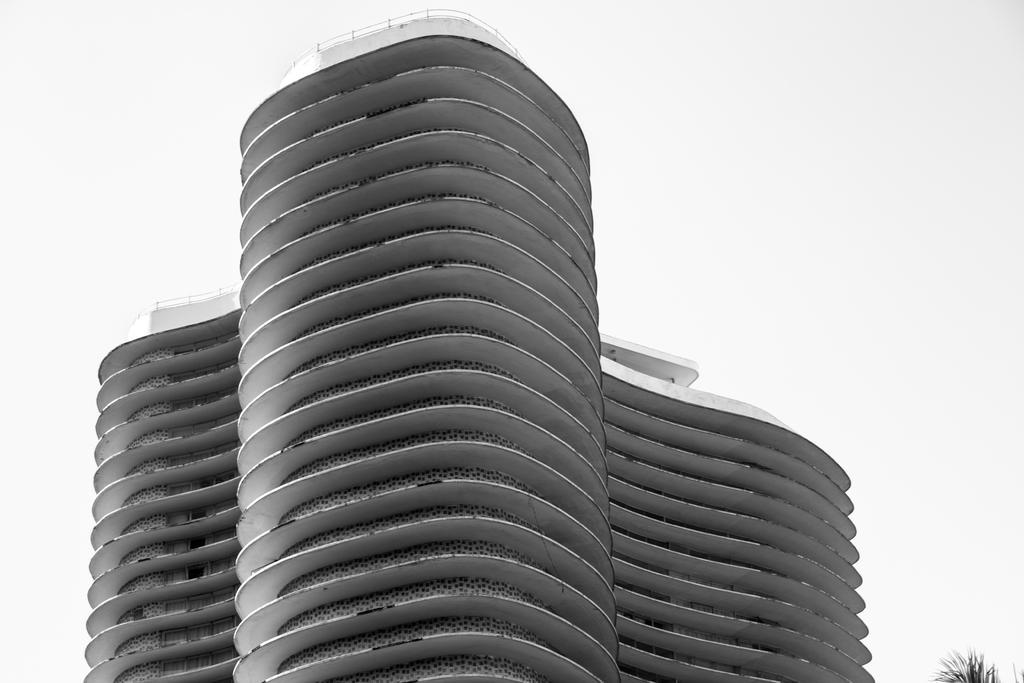Please provide a concise description of this image. In this image, we can see a building. On the rights side, we can see some plants. In the background, there is white color. 